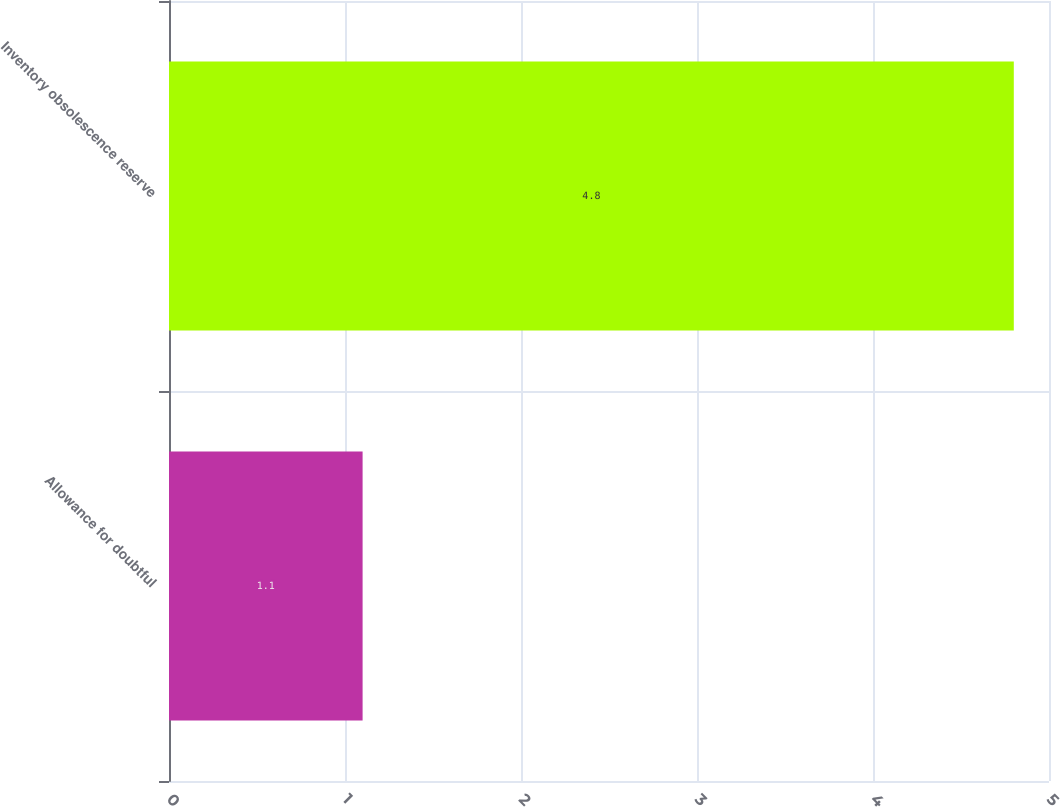<chart> <loc_0><loc_0><loc_500><loc_500><bar_chart><fcel>Allowance for doubtful<fcel>Inventory obsolescence reserve<nl><fcel>1.1<fcel>4.8<nl></chart> 